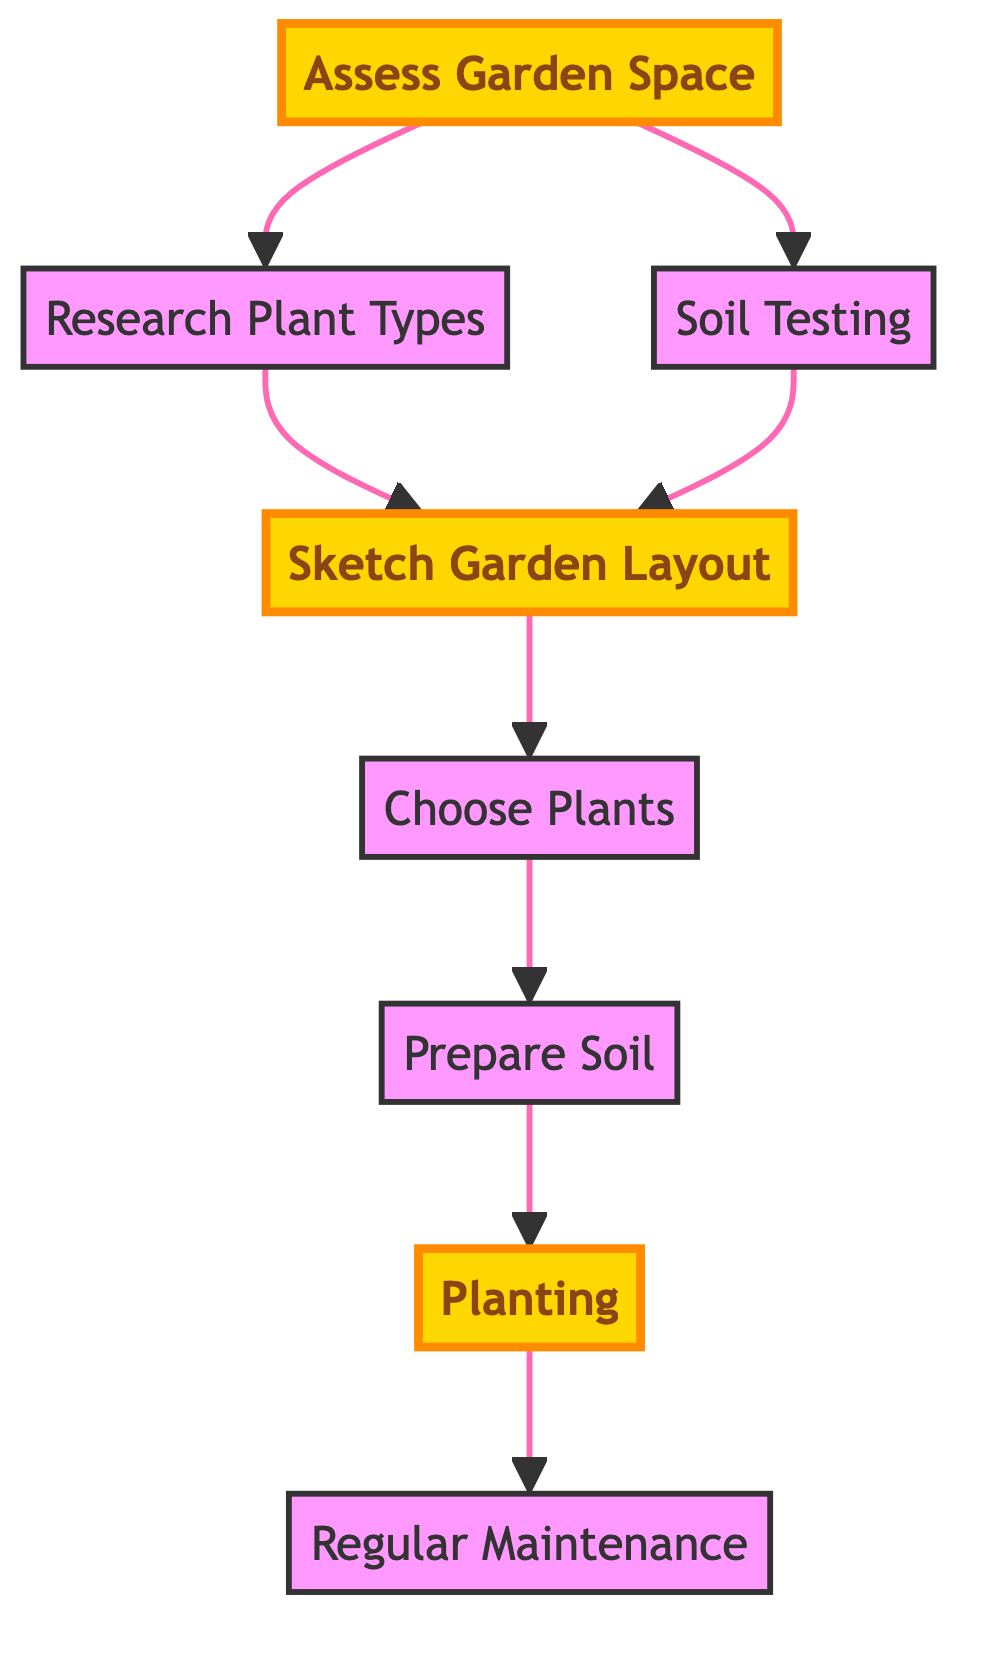What is the first step in the garden planning process? The first step is labeled "Assess Garden Space," which is pointed at by the illustration as the starting node.
Answer: Assess Garden Space How many nodes are in the diagram? The diagram lists 8 distinct nodes, each representing a different step in the garden layout process.
Answer: 8 What is the last step in the garden layout? The last step is indicated as "Regular Maintenance," which is the endpoint of the directed graph.
Answer: Regular Maintenance Which step follows "Choose Plants"? "Prepare Soil" directly follows "Choose Plants" according to the directed edges in the diagram.
Answer: Prepare Soil What are the two immediate steps after "Planting"? After "Planting," the only immediate step is "Regular Maintenance," as indicated by the directed edge. However, focusing on the steps before "Planting," it includes "Prepare Soil" as well.
Answer: Regular Maintenance What is the relationship between "Soil Testing" and "Sketch Garden Layout"? "Soil Testing" and "Sketch Garden Layout" are both related to "Sketch Garden Layout" because they both point to it with directed edges indicating a prerequisite relationship.
Answer: Directed edges What must be done before "Choose Plants"? It is necessary to complete the step "Sketch Garden Layout" before one can choose plants, as indicated by the arrows leading to "Choose Plants."
Answer: Sketch Garden Layout Is "Research Plant Types" a prerequisite for "Planting"? "Research Plant Types" is not directly a prerequisite for "Planting," as it connects to "Sketch Garden Layout," which is a prerequisite. Therefore, the answer is no.
Answer: No 